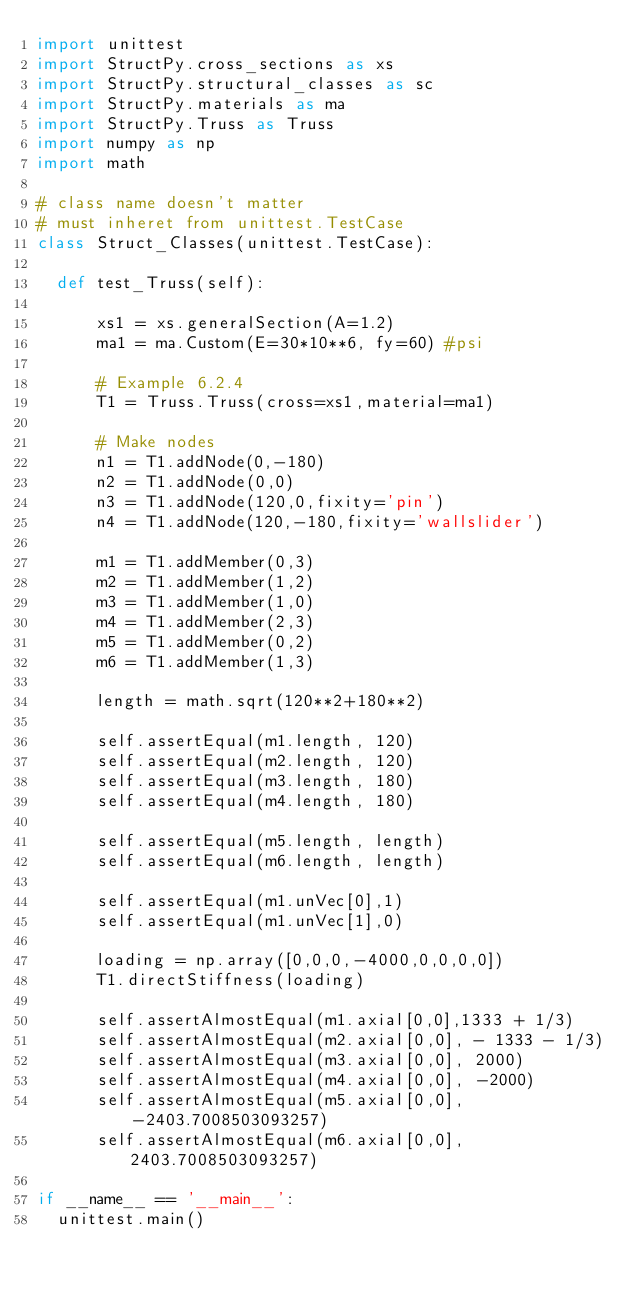<code> <loc_0><loc_0><loc_500><loc_500><_Python_>import unittest
import StructPy.cross_sections as xs
import StructPy.structural_classes as sc
import StructPy.materials as ma
import StructPy.Truss as Truss
import numpy as np
import math

# class name doesn't matter
# must inheret from unittest.TestCase
class Struct_Classes(unittest.TestCase):
	
	def test_Truss(self):
			
			xs1 = xs.generalSection(A=1.2)
			ma1 = ma.Custom(E=30*10**6, fy=60) #psi
			
			# Example 6.2.4
			T1 = Truss.Truss(cross=xs1,material=ma1)
			
			# Make nodes
			n1 = T1.addNode(0,-180)
			n2 = T1.addNode(0,0)
			n3 = T1.addNode(120,0,fixity='pin')
			n4 = T1.addNode(120,-180,fixity='wallslider')
			
			m1 = T1.addMember(0,3)
			m2 = T1.addMember(1,2)
			m3 = T1.addMember(1,0)
			m4 = T1.addMember(2,3)
			m5 = T1.addMember(0,2)
			m6 = T1.addMember(1,3)
			
			length = math.sqrt(120**2+180**2)
			
			self.assertEqual(m1.length, 120)
			self.assertEqual(m2.length, 120)
			self.assertEqual(m3.length, 180)
			self.assertEqual(m4.length, 180)
			
			self.assertEqual(m5.length, length)
			self.assertEqual(m6.length, length)
			
			self.assertEqual(m1.unVec[0],1)
			self.assertEqual(m1.unVec[1],0)
			
			loading = np.array([0,0,0,-4000,0,0,0,0])
			T1.directStiffness(loading)
			
			self.assertAlmostEqual(m1.axial[0,0],1333 + 1/3)
			self.assertAlmostEqual(m2.axial[0,0], - 1333 - 1/3)
			self.assertAlmostEqual(m3.axial[0,0], 2000)
			self.assertAlmostEqual(m4.axial[0,0], -2000)
			self.assertAlmostEqual(m5.axial[0,0], -2403.7008503093257)
			self.assertAlmostEqual(m6.axial[0,0], 2403.7008503093257)
			
if __name__ == '__main__':
	unittest.main()
</code> 